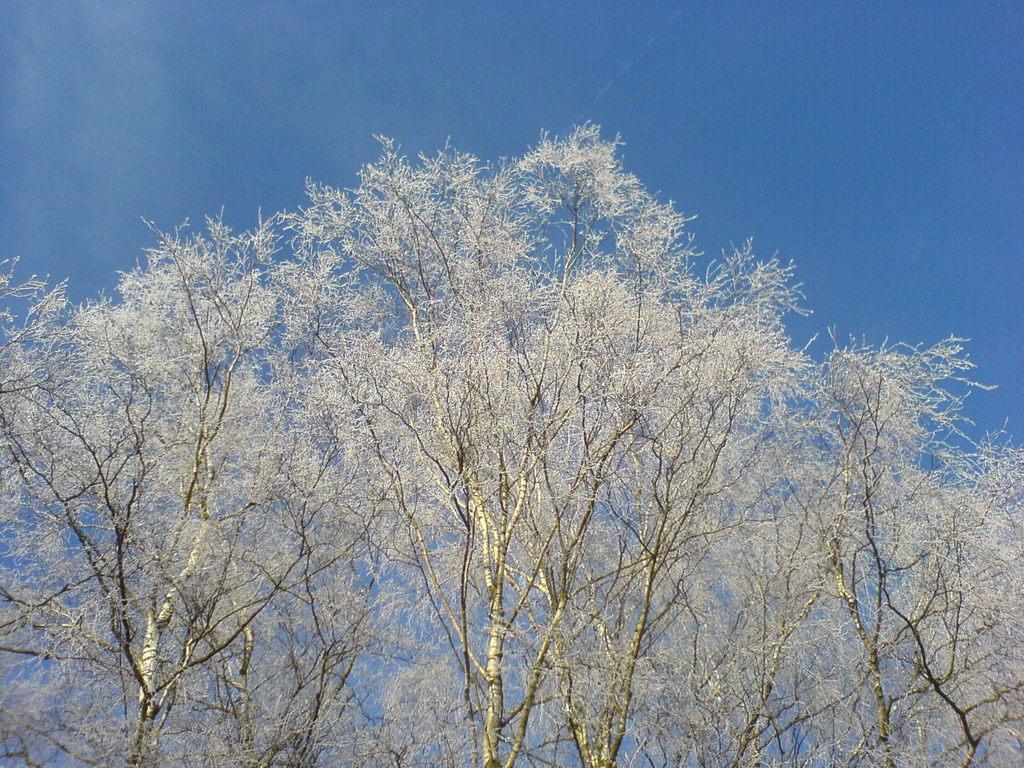Could you give a brief overview of what you see in this image? In the center of the image we can see trees. In the background there is sky. 